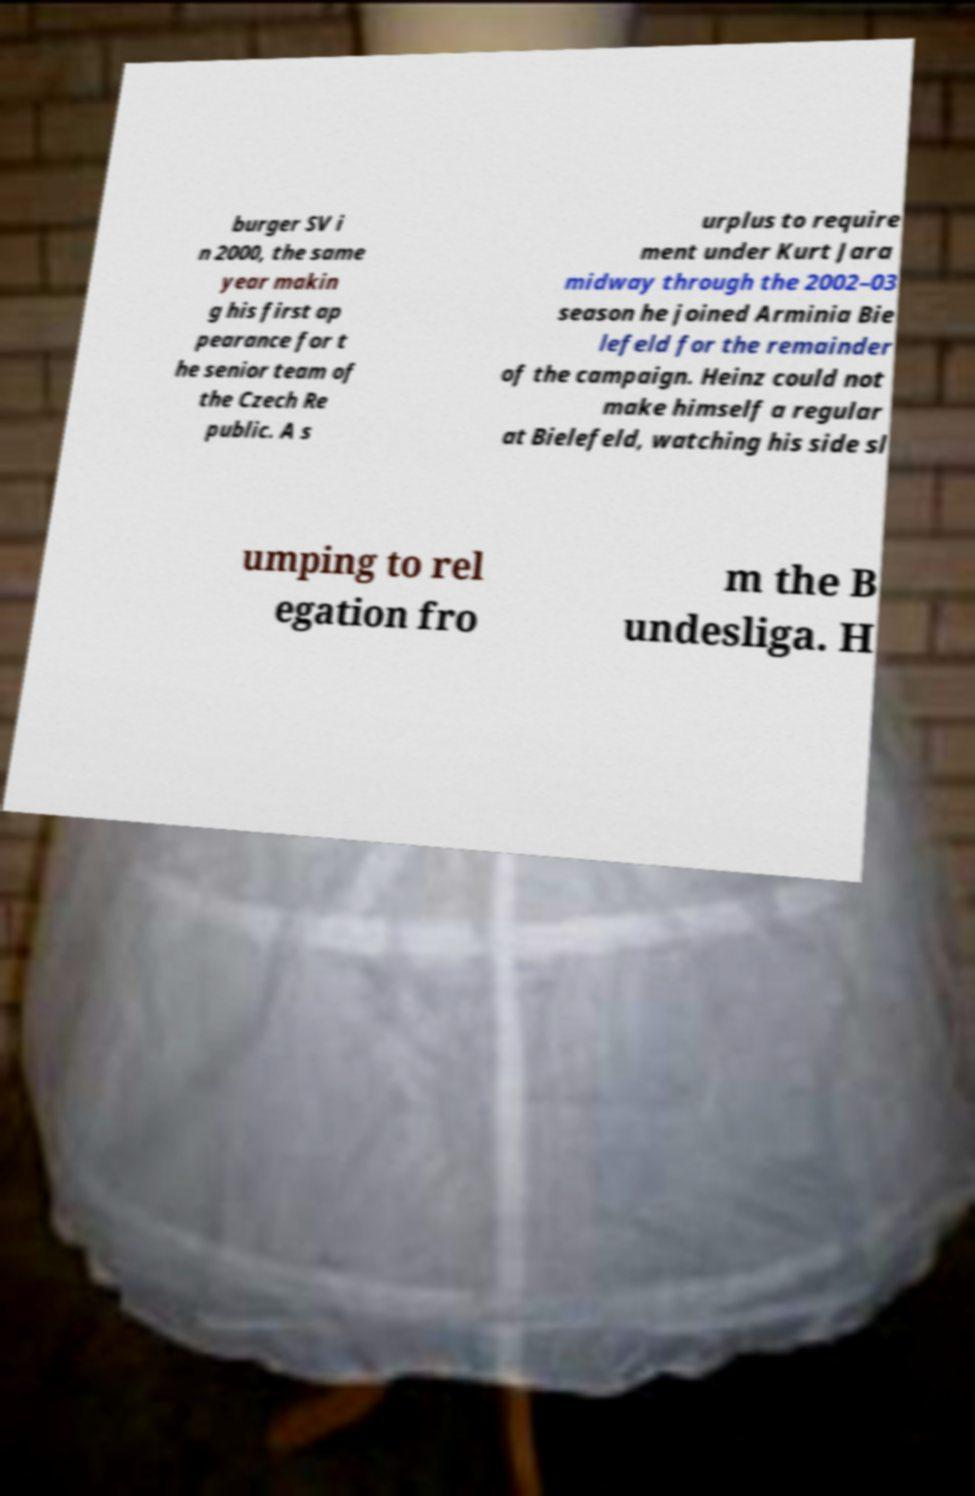What messages or text are displayed in this image? I need them in a readable, typed format. burger SV i n 2000, the same year makin g his first ap pearance for t he senior team of the Czech Re public. A s urplus to require ment under Kurt Jara midway through the 2002–03 season he joined Arminia Bie lefeld for the remainder of the campaign. Heinz could not make himself a regular at Bielefeld, watching his side sl umping to rel egation fro m the B undesliga. H 